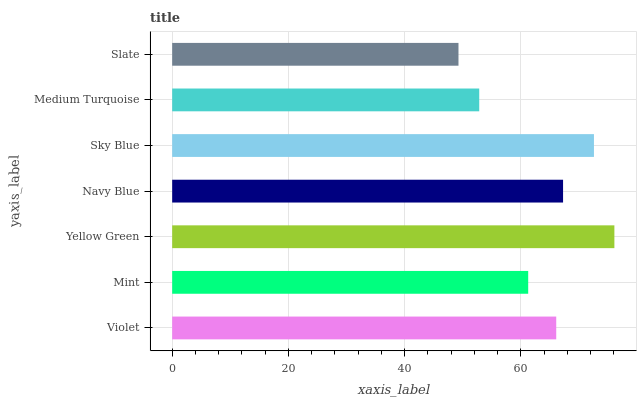Is Slate the minimum?
Answer yes or no. Yes. Is Yellow Green the maximum?
Answer yes or no. Yes. Is Mint the minimum?
Answer yes or no. No. Is Mint the maximum?
Answer yes or no. No. Is Violet greater than Mint?
Answer yes or no. Yes. Is Mint less than Violet?
Answer yes or no. Yes. Is Mint greater than Violet?
Answer yes or no. No. Is Violet less than Mint?
Answer yes or no. No. Is Violet the high median?
Answer yes or no. Yes. Is Violet the low median?
Answer yes or no. Yes. Is Medium Turquoise the high median?
Answer yes or no. No. Is Slate the low median?
Answer yes or no. No. 